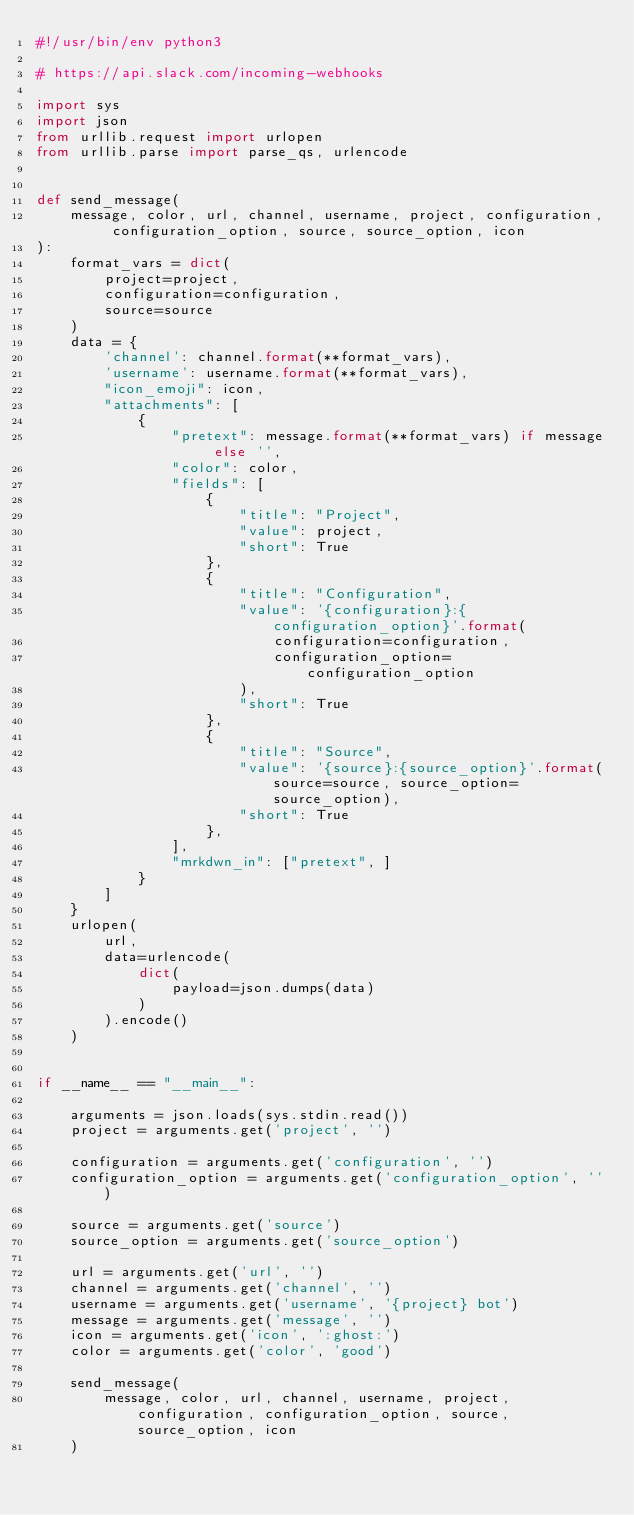Convert code to text. <code><loc_0><loc_0><loc_500><loc_500><_Python_>#!/usr/bin/env python3

# https://api.slack.com/incoming-webhooks

import sys
import json
from urllib.request import urlopen
from urllib.parse import parse_qs, urlencode


def send_message(
    message, color, url, channel, username, project, configuration, configuration_option, source, source_option, icon
):
    format_vars = dict(
        project=project,
        configuration=configuration,
        source=source
    )
    data = {
        'channel': channel.format(**format_vars),
        'username': username.format(**format_vars),
        "icon_emoji": icon,
        "attachments": [
            {
                "pretext": message.format(**format_vars) if message else '',
                "color": color,
                "fields": [
                    {
                        "title": "Project",
                        "value": project,
                        "short": True
                    },
                    {
                        "title": "Configuration",
                        "value": '{configuration}:{configuration_option}'.format(
                            configuration=configuration,
                            configuration_option=configuration_option
                        ),
                        "short": True
                    },
                    {
                        "title": "Source",
                        "value": '{source}:{source_option}'.format(source=source, source_option=source_option),
                        "short": True
                    },
                ],
                "mrkdwn_in": ["pretext", ]
            }
        ]
    }
    urlopen(
        url,
        data=urlencode(
            dict(
                payload=json.dumps(data)
            )
        ).encode()
    )


if __name__ == "__main__":

    arguments = json.loads(sys.stdin.read())
    project = arguments.get('project', '')

    configuration = arguments.get('configuration', '')
    configuration_option = arguments.get('configuration_option', '')

    source = arguments.get('source')
    source_option = arguments.get('source_option')

    url = arguments.get('url', '')
    channel = arguments.get('channel', '')
    username = arguments.get('username', '{project} bot')
    message = arguments.get('message', '')
    icon = arguments.get('icon', ':ghost:')
    color = arguments.get('color', 'good')

    send_message(
        message, color, url, channel, username, project, configuration, configuration_option, source, source_option, icon
    )
</code> 